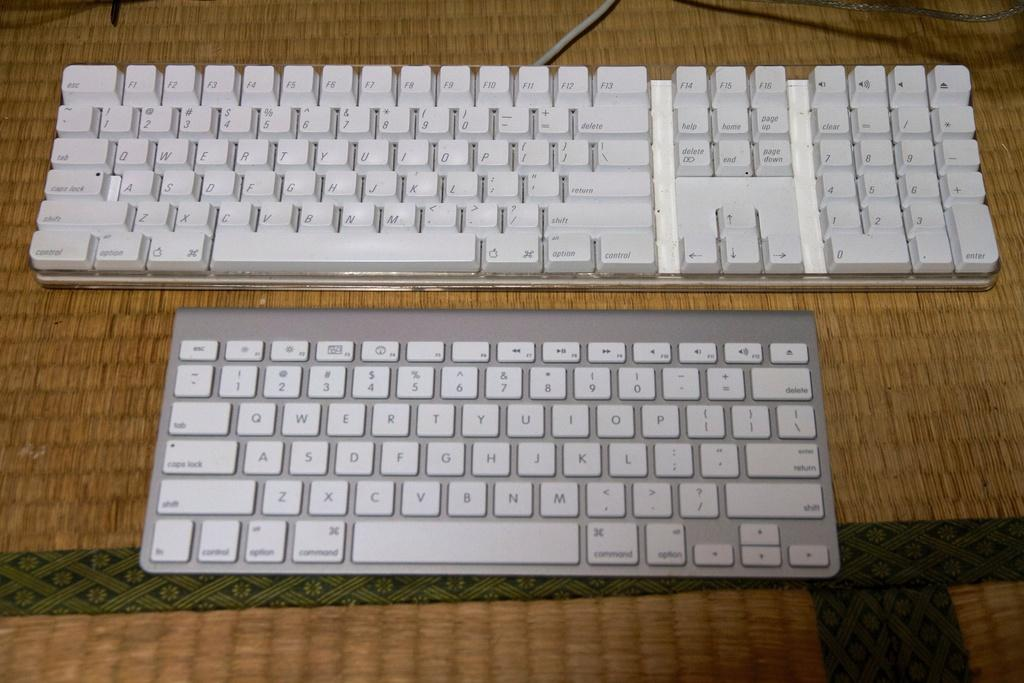<image>
Share a concise interpretation of the image provided. Two qwerty type white keyboards with esc keys 